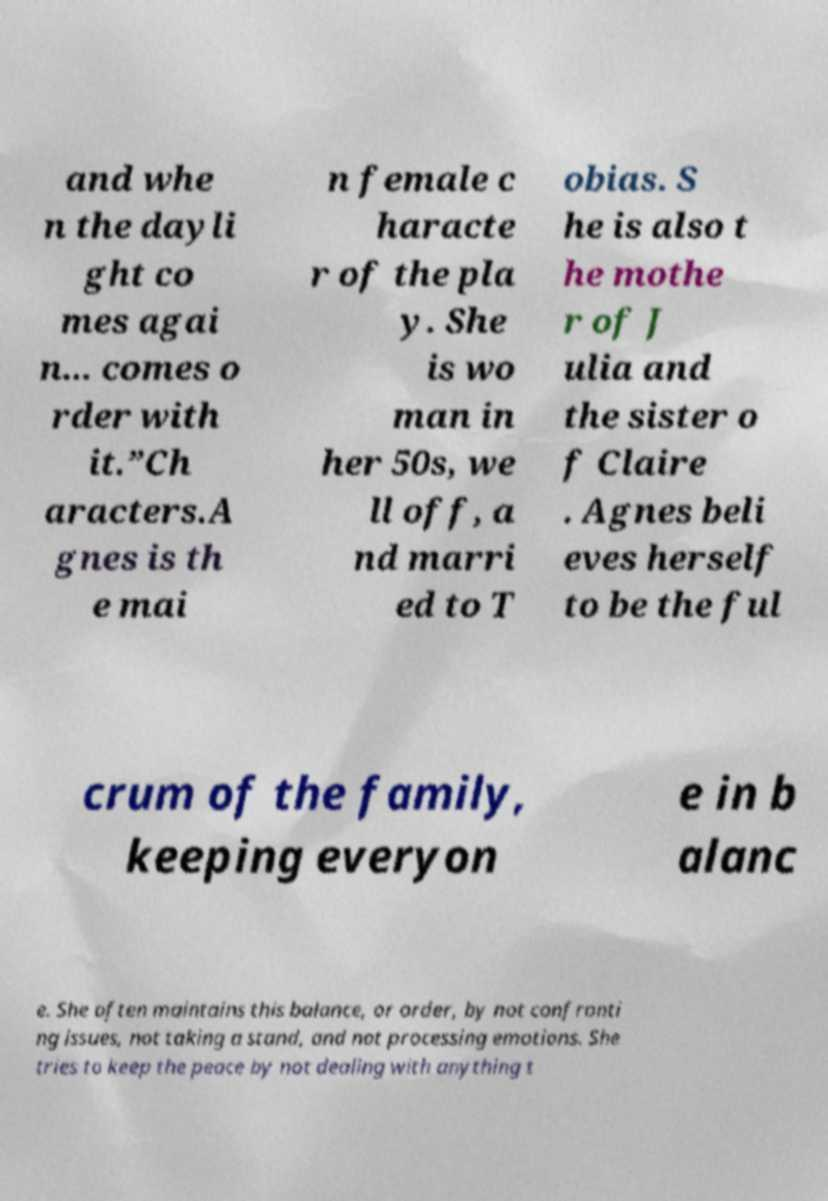Can you accurately transcribe the text from the provided image for me? and whe n the dayli ght co mes agai n... comes o rder with it.”Ch aracters.A gnes is th e mai n female c haracte r of the pla y. She is wo man in her 50s, we ll off, a nd marri ed to T obias. S he is also t he mothe r of J ulia and the sister o f Claire . Agnes beli eves herself to be the ful crum of the family, keeping everyon e in b alanc e. She often maintains this balance, or order, by not confronti ng issues, not taking a stand, and not processing emotions. She tries to keep the peace by not dealing with anything t 